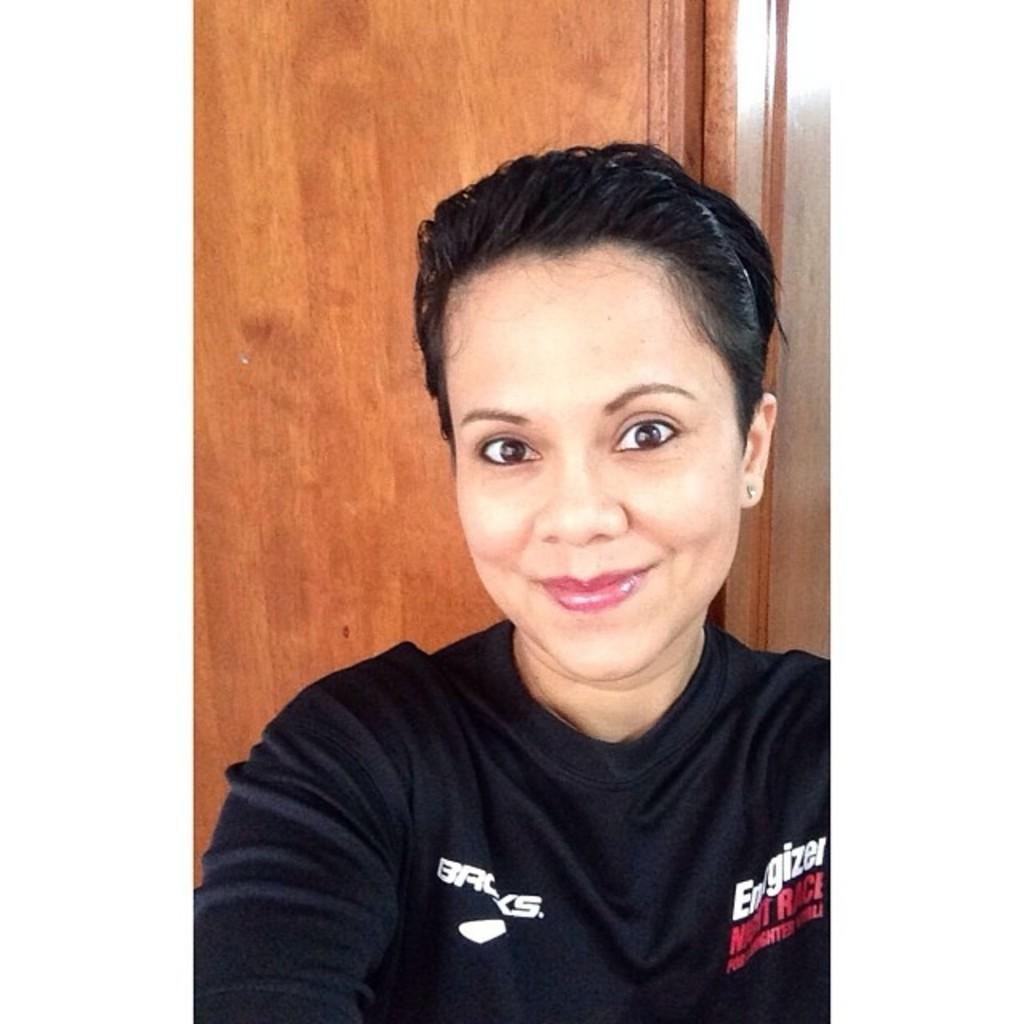<image>
Summarize the visual content of the image. the lady's black sweater has the word Energizer on the right 